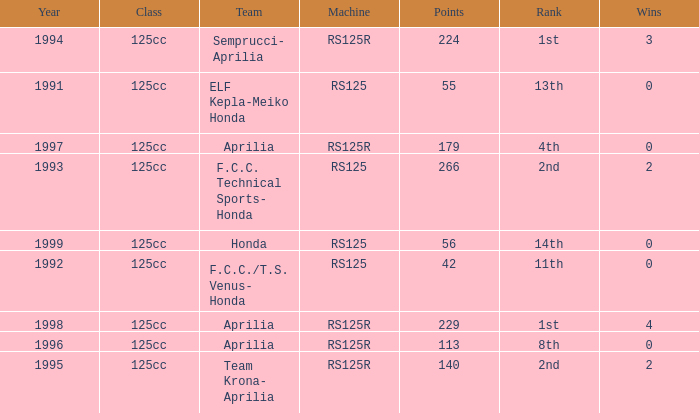Which team had a year over 1995, machine of RS125R, and ranked 1st? Aprilia. 